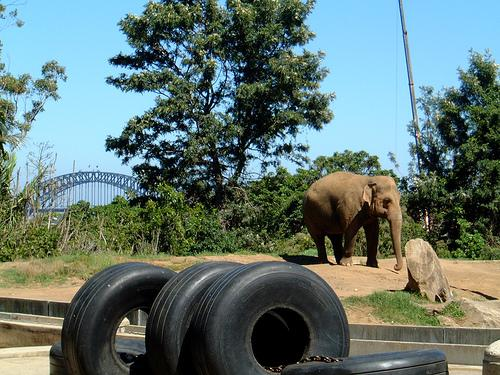Question: what species is shown?
Choices:
A. Tiger.
B. Elephant.
C. Lion.
D. Zebra.
Answer with the letter. Answer: B Question: how many animals are shown?
Choices:
A. Two.
B. Three.
C. Four.
D. One.
Answer with the letter. Answer: D Question: what is the tallest organism in the picture?
Choices:
A. Grass.
B. Person.
C. Flowers.
D. The tree.
Answer with the letter. Answer: D Question: what color is the elephant?
Choices:
A. Black.
B. Gray.
C. White.
D. Tan.
Answer with the letter. Answer: B Question: how many tires are shown?
Choices:
A. 4.
B. 3.
C. 2.
D. 1.
Answer with the letter. Answer: A 